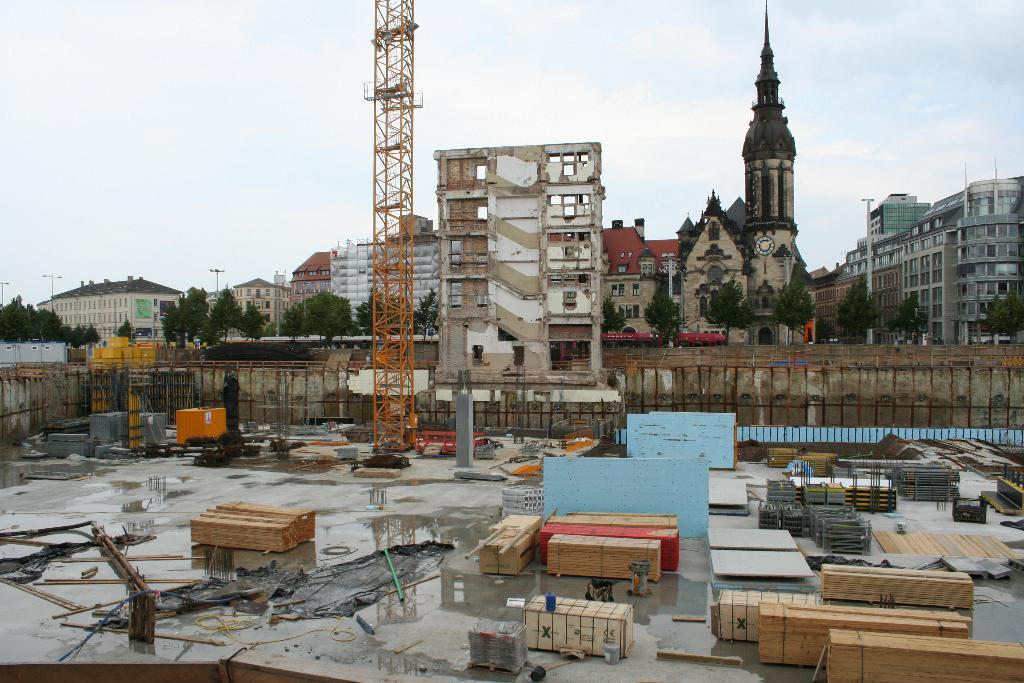What type of materials can be seen in the image? There are lumbers and timber woods in the image. What structures are located in the foreground of the image? There are towers in the foreground of the image. What can be seen in the background of the image? There are buildings and trees in the background of the image. How is the sky depicted in the image? The sky is clear in the background of the image. What type of punishment is being administered to the trees in the image? There is no punishment being administered to the trees in the image; they are simply standing in the background. What emotion can be seen on the lumbers in the image? The lumbers and timber woods in the image are inanimate objects and do not display emotions like anger. 